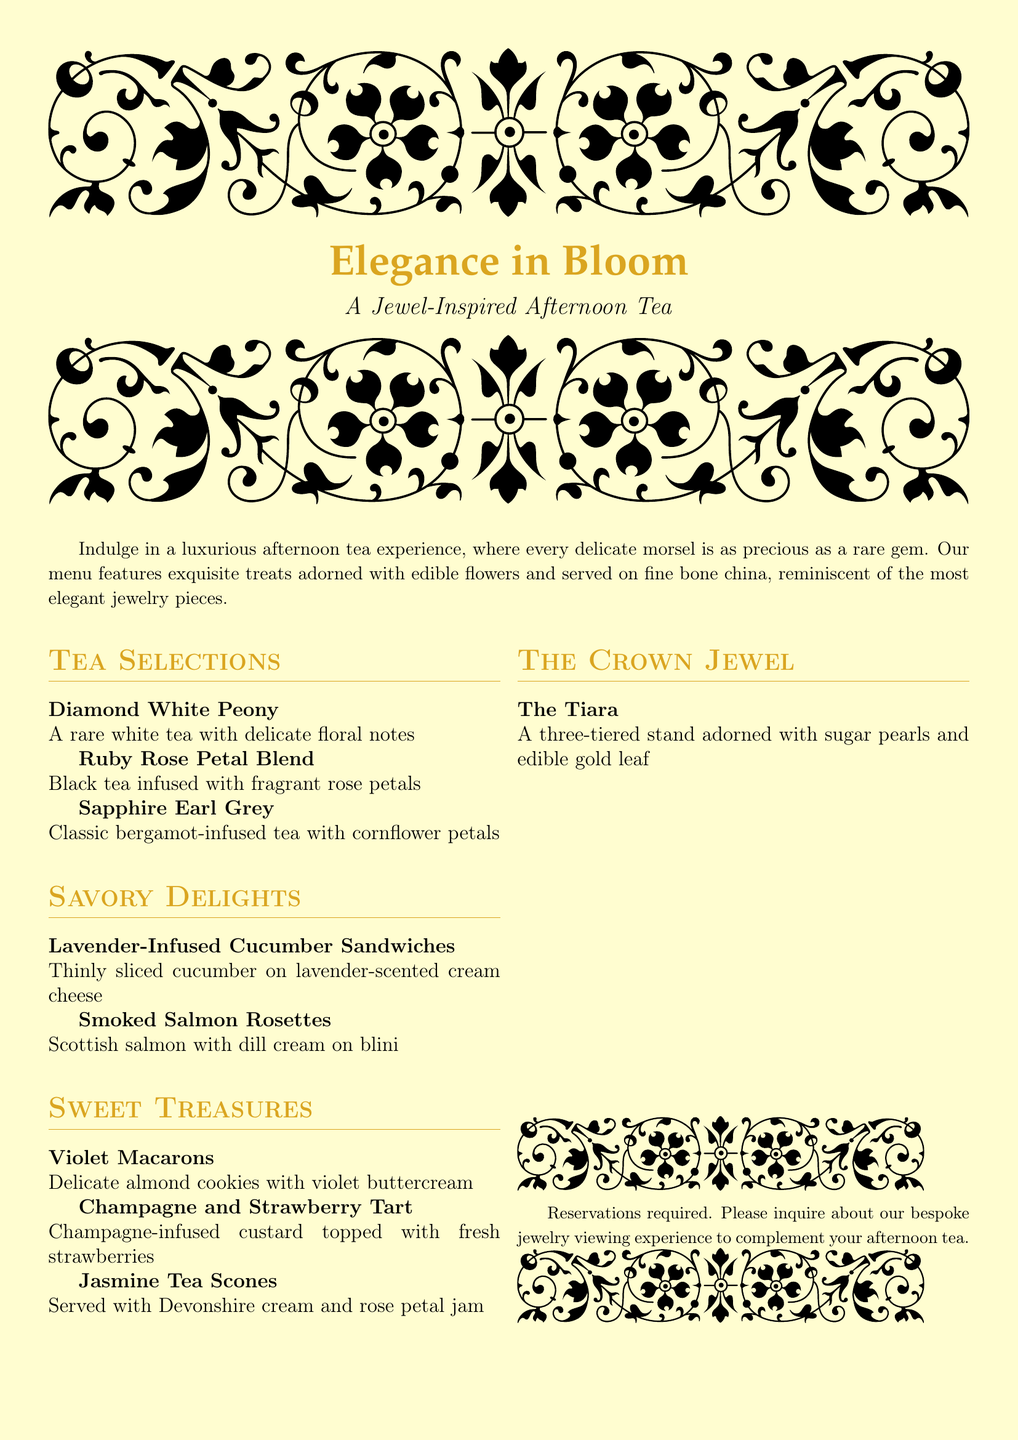what is the title of the menu? The title is prominently displayed at the top of the document, stating the theme of the afternoon tea experience.
Answer: Elegance in Bloom what is the first tea selection listed? The first tea selection is the first item in the 'Tea Selections' section.
Answer: Diamond White Peony how many sweet treasures are mentioned in the menu? The menu lists the number of items in the 'Sweet Treasures' section, where each item is counted.
Answer: Three what is included in 'The Crown Jewel'? This section features a specific item that elevates the afternoon tea experience.
Answer: The Tiara what type of sandwiches are served? The sandwich type can be found under the 'Savory Delights' section of the document.
Answer: Lavender-Infused Cucumber Sandwiches what kind of cream is served with the scones? The type of cream served with the scones is clearly stated in the description under 'Sweet Treasures.'
Answer: Devonshire cream how are the sweets described in the introduction? The introduction of the menu describes the sweets in a particular way that highlights their quality.
Answer: Exquisite treats adorned with edible flowers what must be inquired about to complement the afternoon tea? The document suggests an additional experience that can enhance the tea experience.
Answer: Bespoke jewelry viewing experience 